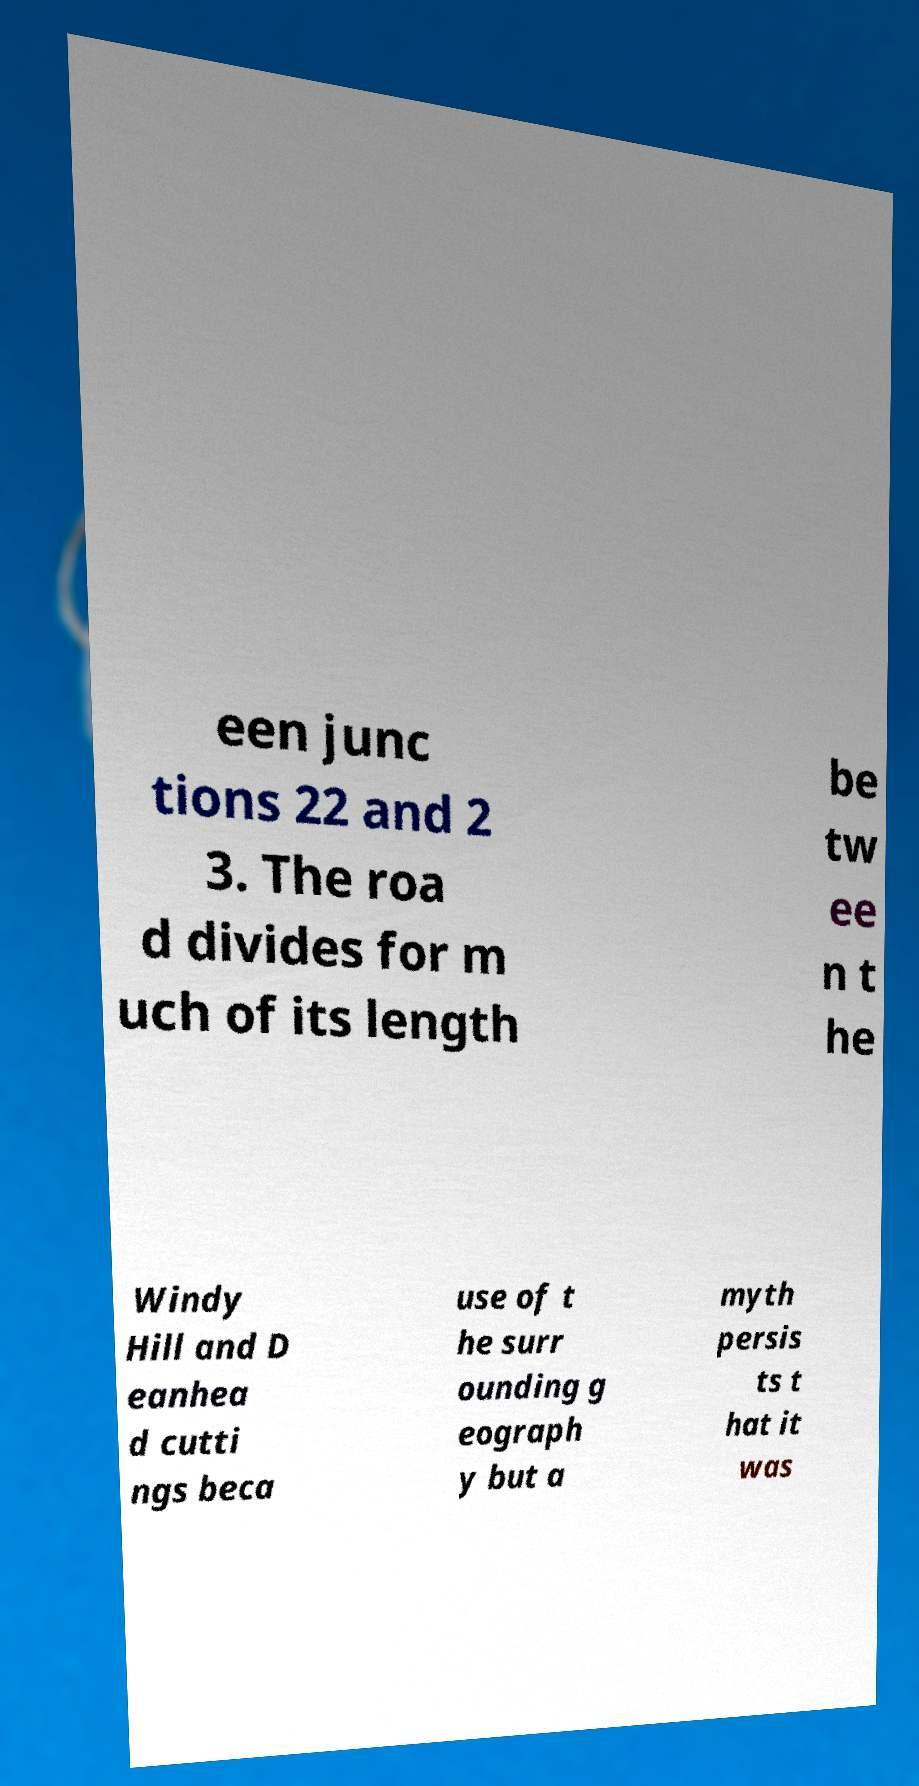There's text embedded in this image that I need extracted. Can you transcribe it verbatim? een junc tions 22 and 2 3. The roa d divides for m uch of its length be tw ee n t he Windy Hill and D eanhea d cutti ngs beca use of t he surr ounding g eograph y but a myth persis ts t hat it was 